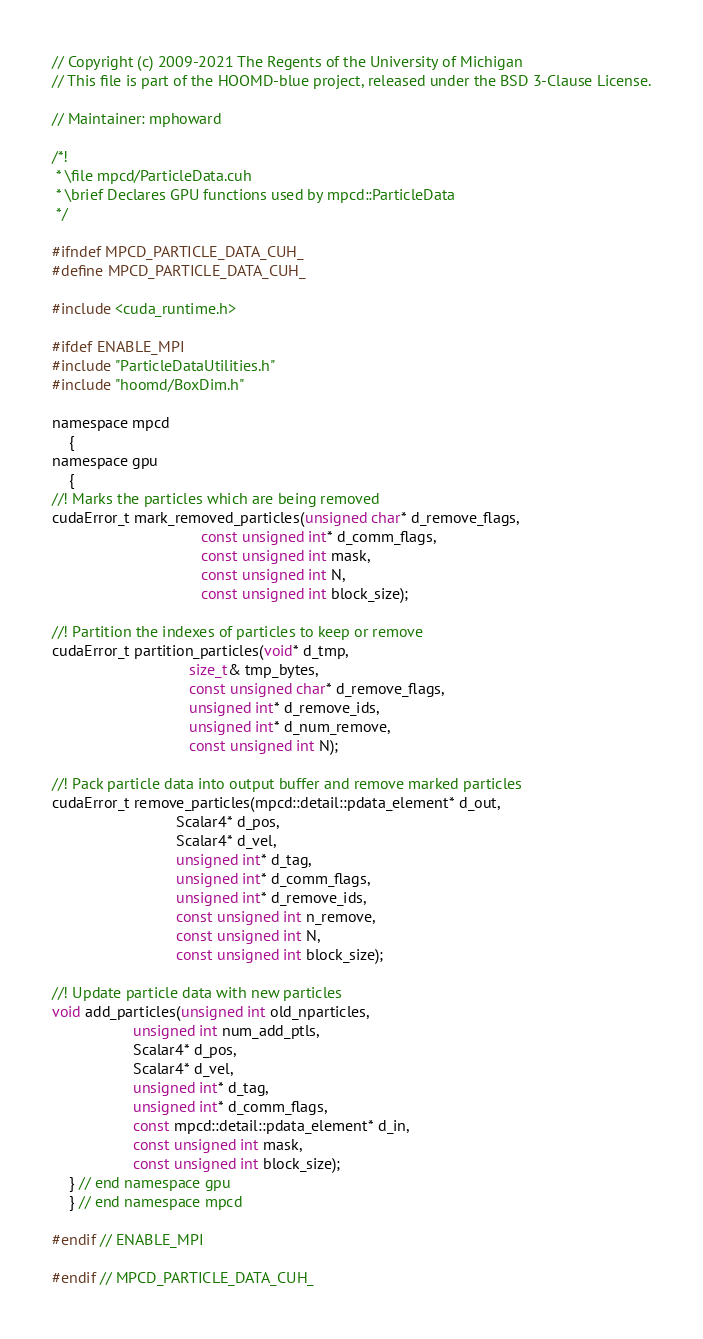<code> <loc_0><loc_0><loc_500><loc_500><_Cuda_>// Copyright (c) 2009-2021 The Regents of the University of Michigan
// This file is part of the HOOMD-blue project, released under the BSD 3-Clause License.

// Maintainer: mphoward

/*!
 * \file mpcd/ParticleData.cuh
 * \brief Declares GPU functions used by mpcd::ParticleData
 */

#ifndef MPCD_PARTICLE_DATA_CUH_
#define MPCD_PARTICLE_DATA_CUH_

#include <cuda_runtime.h>

#ifdef ENABLE_MPI
#include "ParticleDataUtilities.h"
#include "hoomd/BoxDim.h"

namespace mpcd
    {
namespace gpu
    {
//! Marks the particles which are being removed
cudaError_t mark_removed_particles(unsigned char* d_remove_flags,
                                   const unsigned int* d_comm_flags,
                                   const unsigned int mask,
                                   const unsigned int N,
                                   const unsigned int block_size);

//! Partition the indexes of particles to keep or remove
cudaError_t partition_particles(void* d_tmp,
                                size_t& tmp_bytes,
                                const unsigned char* d_remove_flags,
                                unsigned int* d_remove_ids,
                                unsigned int* d_num_remove,
                                const unsigned int N);

//! Pack particle data into output buffer and remove marked particles
cudaError_t remove_particles(mpcd::detail::pdata_element* d_out,
                             Scalar4* d_pos,
                             Scalar4* d_vel,
                             unsigned int* d_tag,
                             unsigned int* d_comm_flags,
                             unsigned int* d_remove_ids,
                             const unsigned int n_remove,
                             const unsigned int N,
                             const unsigned int block_size);

//! Update particle data with new particles
void add_particles(unsigned int old_nparticles,
                   unsigned int num_add_ptls,
                   Scalar4* d_pos,
                   Scalar4* d_vel,
                   unsigned int* d_tag,
                   unsigned int* d_comm_flags,
                   const mpcd::detail::pdata_element* d_in,
                   const unsigned int mask,
                   const unsigned int block_size);
    } // end namespace gpu
    } // end namespace mpcd

#endif // ENABLE_MPI

#endif // MPCD_PARTICLE_DATA_CUH_
</code> 